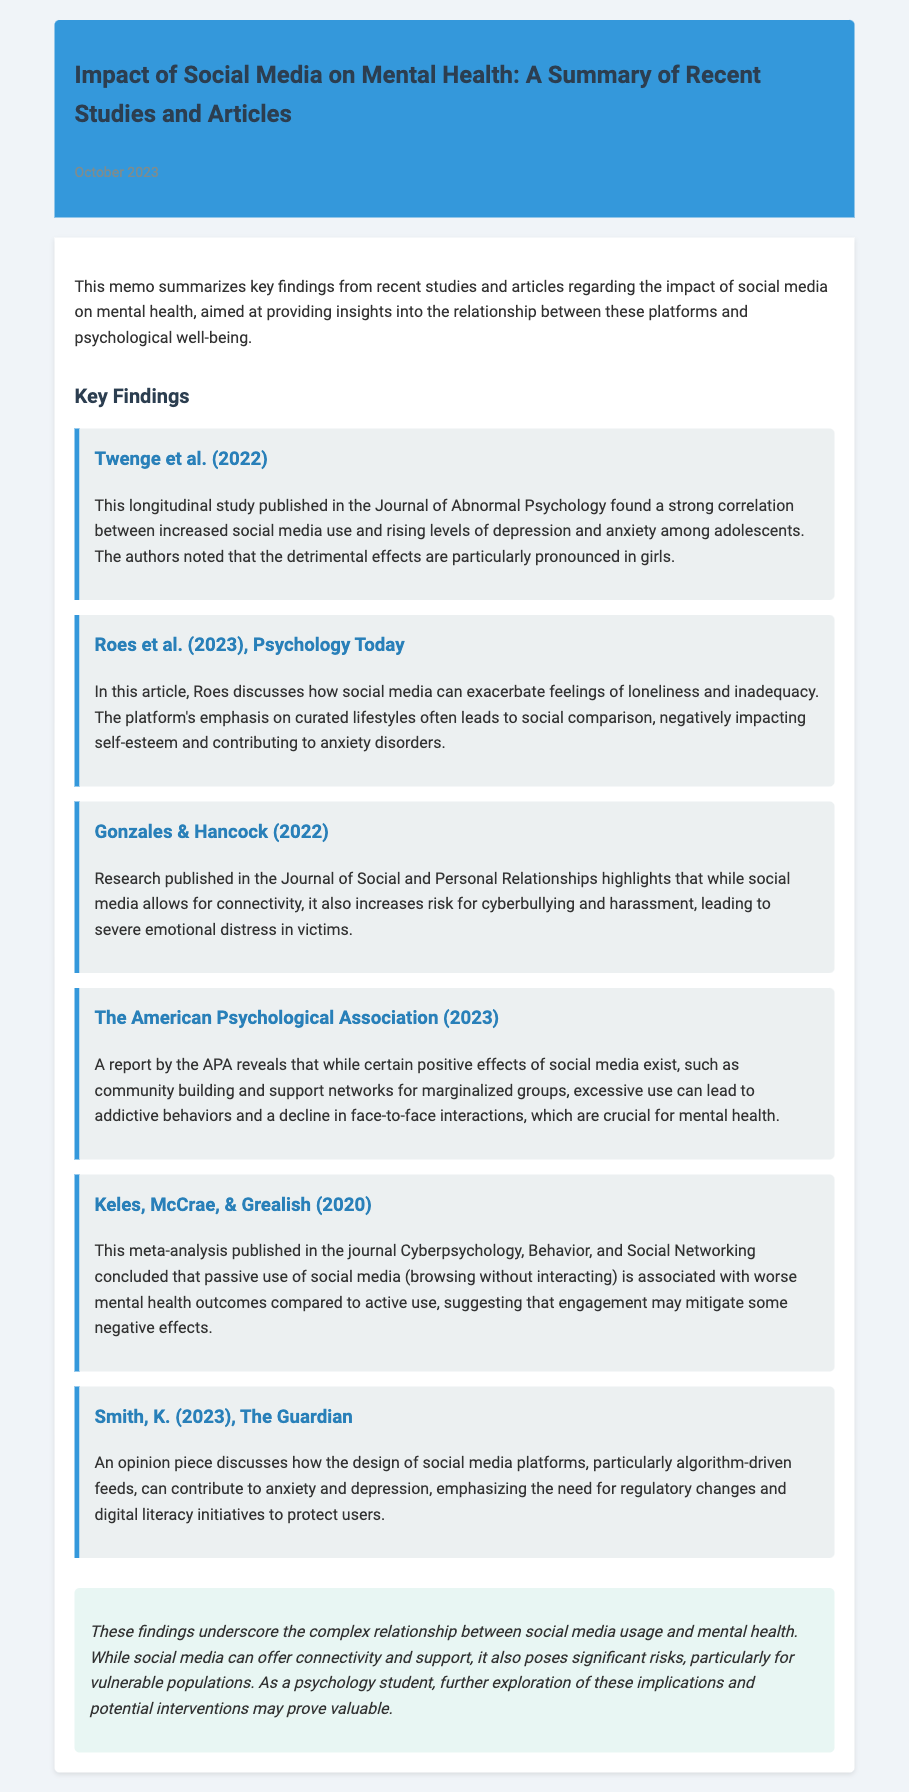What is the primary focus of the memo? The memo summarizes key findings from recent studies and articles regarding the impact of social media on mental health.
Answer: impact of social media on mental health When was this memo published? The publication date is provided in the memo.
Answer: October 2023 Which study reported a strong correlation between social media use and rising levels of depression and anxiety among adolescents? This information is found in the first key finding by Twenge et al.
Answer: Twenge et al. (2022) What negative effect is discussed by Roes in relation to social media usage? The article by Roes discusses how social media exacerbates feelings of loneliness and inadequacy.
Answer: loneliness and inadequacy What is one potential positive effect of social media mentioned in the summary? The American Psychological Association report mentions community building as a positive effect.
Answer: community building Which group of individuals is particularly affected by the detrimental effects of social media according to Twenge et al. (2022)? The study indicates that the detrimental effects particularly impact girls.
Answer: girls What type of social media use is associated with worse mental health outcomes according to Keles, McCrae, & Grealish? The meta-analysis distinguishes between active and passive use regarding mental health outcomes.
Answer: passive use What does Smith's opinion piece emphasize regarding social media platforms? Smith discusses the contributions of algorithm-driven feeds to anxiety and depression.
Answer: algorithm-driven feeds What is a suggested intervention mentioned in the memo’s conclusion? The conclusion highlights the need for regulatory changes and digital literacy initiatives.
Answer: regulatory changes and digital literacy initiatives 